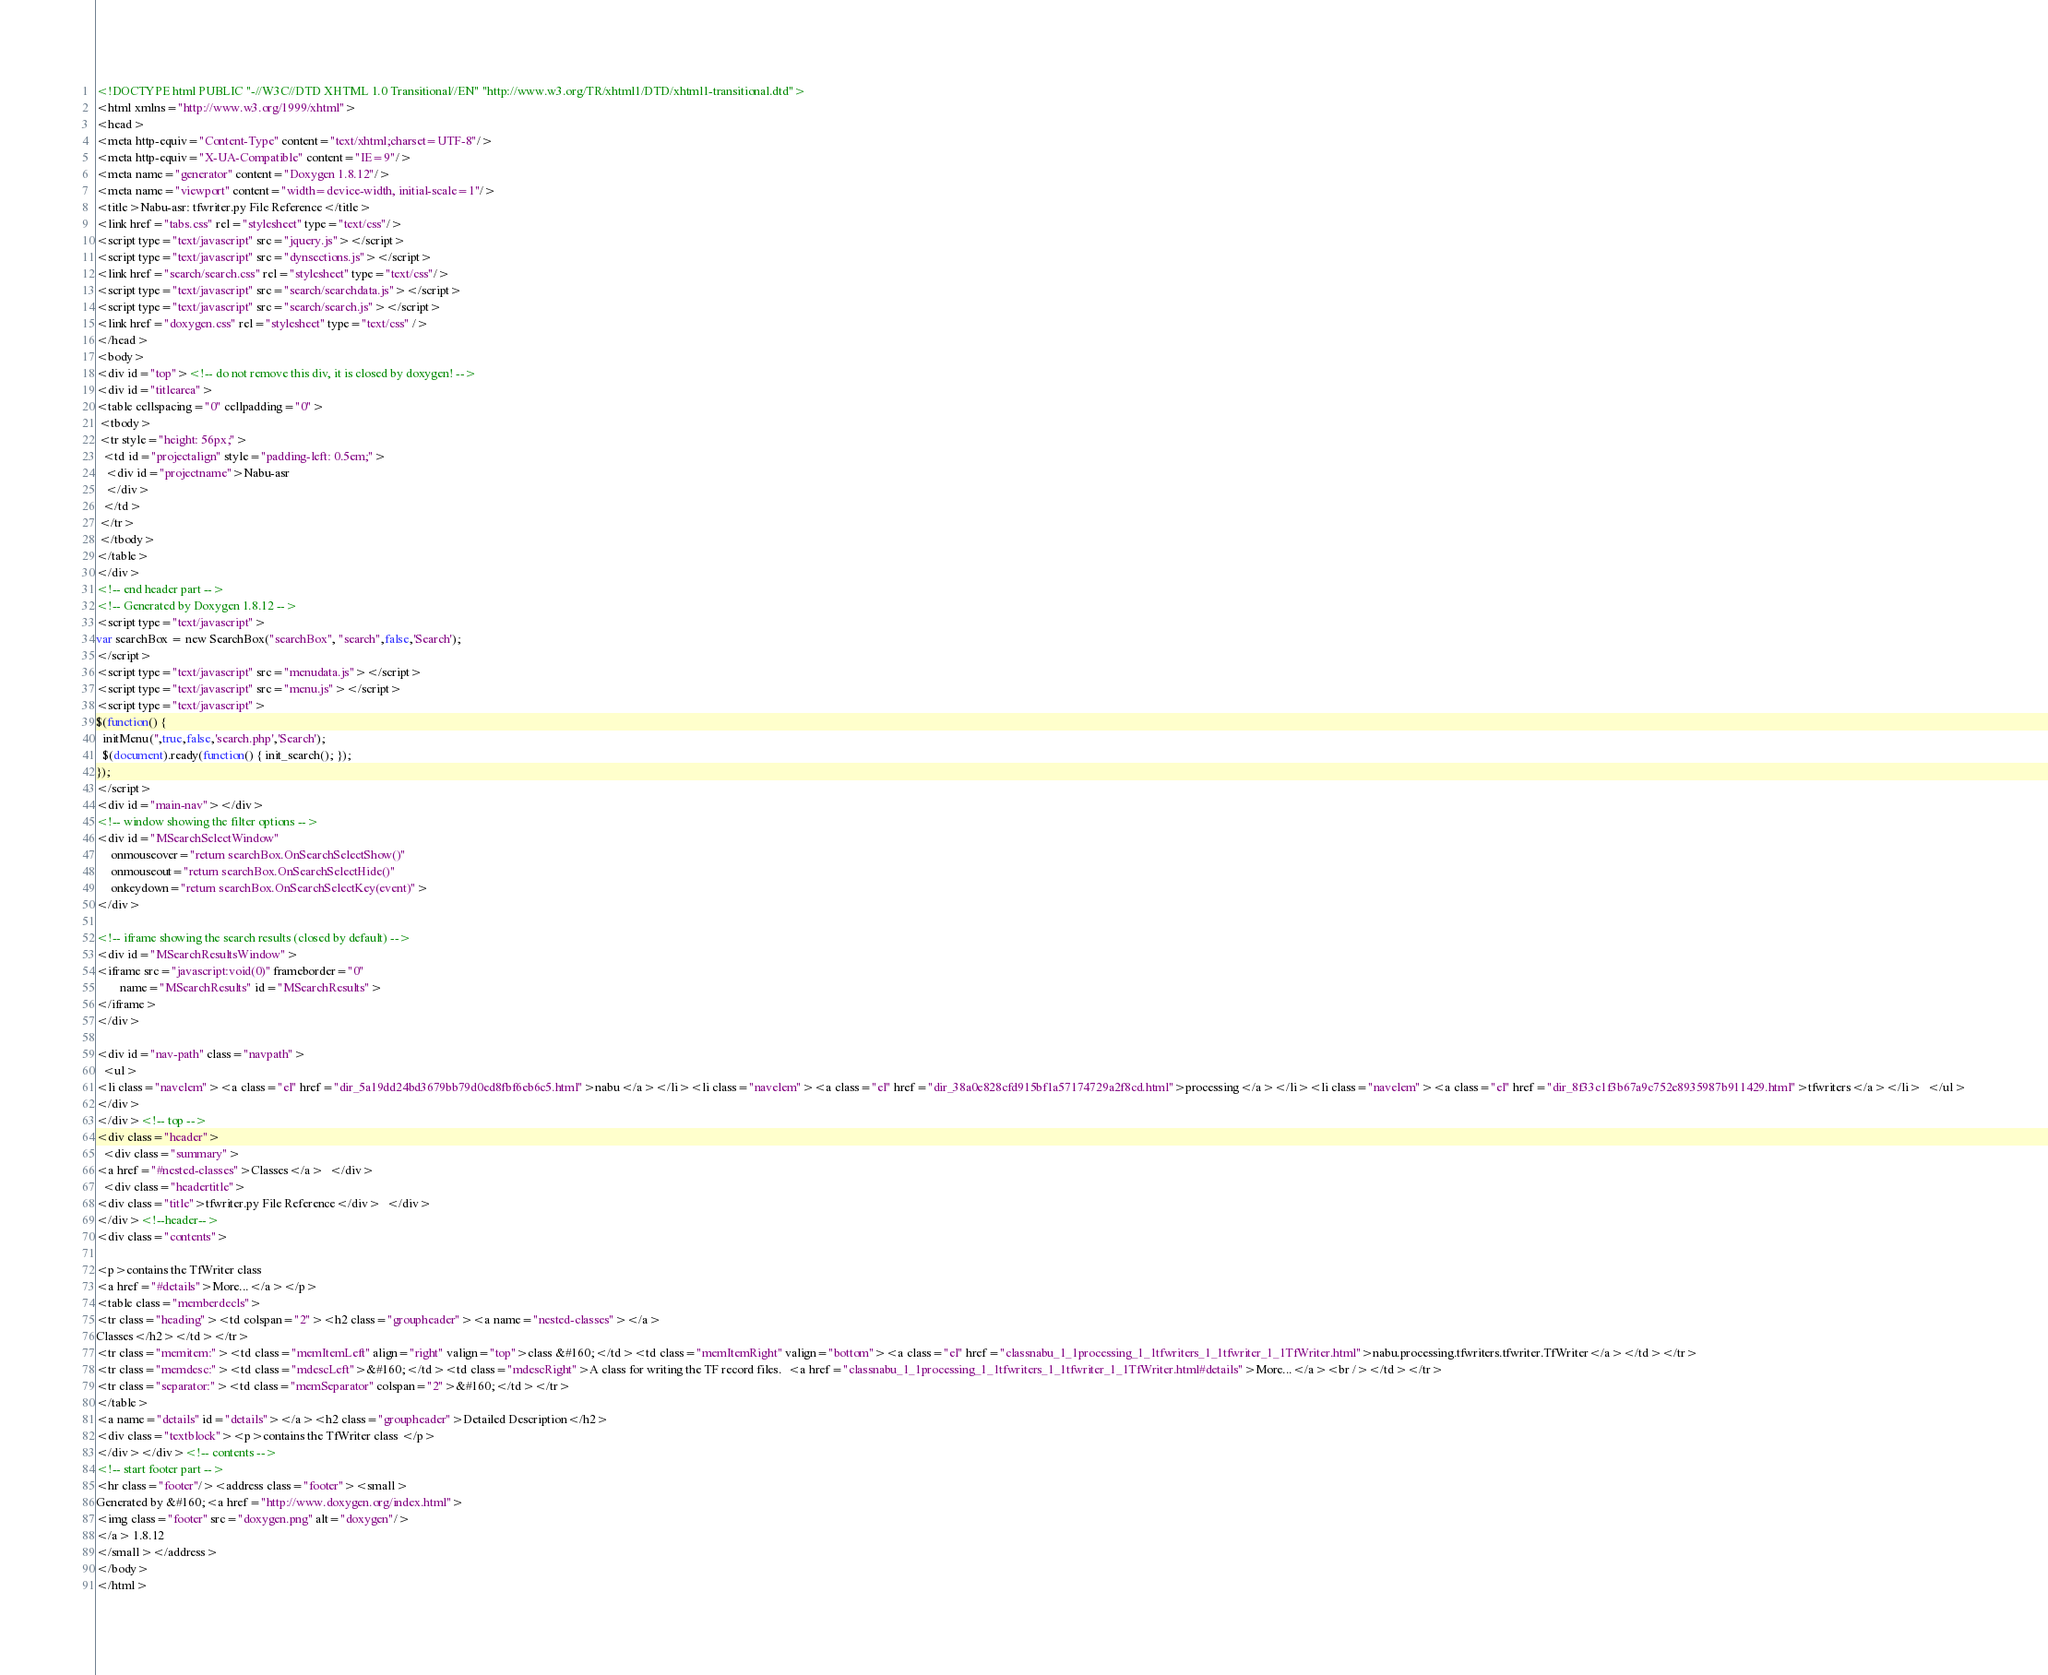<code> <loc_0><loc_0><loc_500><loc_500><_HTML_><!DOCTYPE html PUBLIC "-//W3C//DTD XHTML 1.0 Transitional//EN" "http://www.w3.org/TR/xhtml1/DTD/xhtml1-transitional.dtd">
<html xmlns="http://www.w3.org/1999/xhtml">
<head>
<meta http-equiv="Content-Type" content="text/xhtml;charset=UTF-8"/>
<meta http-equiv="X-UA-Compatible" content="IE=9"/>
<meta name="generator" content="Doxygen 1.8.12"/>
<meta name="viewport" content="width=device-width, initial-scale=1"/>
<title>Nabu-asr: tfwriter.py File Reference</title>
<link href="tabs.css" rel="stylesheet" type="text/css"/>
<script type="text/javascript" src="jquery.js"></script>
<script type="text/javascript" src="dynsections.js"></script>
<link href="search/search.css" rel="stylesheet" type="text/css"/>
<script type="text/javascript" src="search/searchdata.js"></script>
<script type="text/javascript" src="search/search.js"></script>
<link href="doxygen.css" rel="stylesheet" type="text/css" />
</head>
<body>
<div id="top"><!-- do not remove this div, it is closed by doxygen! -->
<div id="titlearea">
<table cellspacing="0" cellpadding="0">
 <tbody>
 <tr style="height: 56px;">
  <td id="projectalign" style="padding-left: 0.5em;">
   <div id="projectname">Nabu-asr
   </div>
  </td>
 </tr>
 </tbody>
</table>
</div>
<!-- end header part -->
<!-- Generated by Doxygen 1.8.12 -->
<script type="text/javascript">
var searchBox = new SearchBox("searchBox", "search",false,'Search');
</script>
<script type="text/javascript" src="menudata.js"></script>
<script type="text/javascript" src="menu.js"></script>
<script type="text/javascript">
$(function() {
  initMenu('',true,false,'search.php','Search');
  $(document).ready(function() { init_search(); });
});
</script>
<div id="main-nav"></div>
<!-- window showing the filter options -->
<div id="MSearchSelectWindow"
     onmouseover="return searchBox.OnSearchSelectShow()"
     onmouseout="return searchBox.OnSearchSelectHide()"
     onkeydown="return searchBox.OnSearchSelectKey(event)">
</div>

<!-- iframe showing the search results (closed by default) -->
<div id="MSearchResultsWindow">
<iframe src="javascript:void(0)" frameborder="0" 
        name="MSearchResults" id="MSearchResults">
</iframe>
</div>

<div id="nav-path" class="navpath">
  <ul>
<li class="navelem"><a class="el" href="dir_5a19dd24bd3679bb79d0ed8fbf6eb6c5.html">nabu</a></li><li class="navelem"><a class="el" href="dir_38a0e828cfd915bf1a57174729a2f8cd.html">processing</a></li><li class="navelem"><a class="el" href="dir_8f33c1f3b67a9c752e8935987b911429.html">tfwriters</a></li>  </ul>
</div>
</div><!-- top -->
<div class="header">
  <div class="summary">
<a href="#nested-classes">Classes</a>  </div>
  <div class="headertitle">
<div class="title">tfwriter.py File Reference</div>  </div>
</div><!--header-->
<div class="contents">

<p>contains the TfWriter class  
<a href="#details">More...</a></p>
<table class="memberdecls">
<tr class="heading"><td colspan="2"><h2 class="groupheader"><a name="nested-classes"></a>
Classes</h2></td></tr>
<tr class="memitem:"><td class="memItemLeft" align="right" valign="top">class &#160;</td><td class="memItemRight" valign="bottom"><a class="el" href="classnabu_1_1processing_1_1tfwriters_1_1tfwriter_1_1TfWriter.html">nabu.processing.tfwriters.tfwriter.TfWriter</a></td></tr>
<tr class="memdesc:"><td class="mdescLeft">&#160;</td><td class="mdescRight">A class for writing the TF record files.  <a href="classnabu_1_1processing_1_1tfwriters_1_1tfwriter_1_1TfWriter.html#details">More...</a><br /></td></tr>
<tr class="separator:"><td class="memSeparator" colspan="2">&#160;</td></tr>
</table>
<a name="details" id="details"></a><h2 class="groupheader">Detailed Description</h2>
<div class="textblock"><p>contains the TfWriter class </p>
</div></div><!-- contents -->
<!-- start footer part -->
<hr class="footer"/><address class="footer"><small>
Generated by &#160;<a href="http://www.doxygen.org/index.html">
<img class="footer" src="doxygen.png" alt="doxygen"/>
</a> 1.8.12
</small></address>
</body>
</html>
</code> 